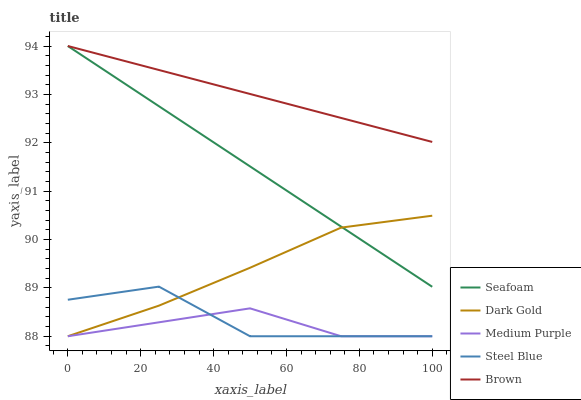Does Medium Purple have the minimum area under the curve?
Answer yes or no. Yes. Does Brown have the maximum area under the curve?
Answer yes or no. Yes. Does Steel Blue have the minimum area under the curve?
Answer yes or no. No. Does Steel Blue have the maximum area under the curve?
Answer yes or no. No. Is Brown the smoothest?
Answer yes or no. Yes. Is Steel Blue the roughest?
Answer yes or no. Yes. Is Steel Blue the smoothest?
Answer yes or no. No. Is Brown the roughest?
Answer yes or no. No. Does Medium Purple have the lowest value?
Answer yes or no. Yes. Does Brown have the lowest value?
Answer yes or no. No. Does Seafoam have the highest value?
Answer yes or no. Yes. Does Steel Blue have the highest value?
Answer yes or no. No. Is Medium Purple less than Brown?
Answer yes or no. Yes. Is Seafoam greater than Steel Blue?
Answer yes or no. Yes. Does Dark Gold intersect Seafoam?
Answer yes or no. Yes. Is Dark Gold less than Seafoam?
Answer yes or no. No. Is Dark Gold greater than Seafoam?
Answer yes or no. No. Does Medium Purple intersect Brown?
Answer yes or no. No. 